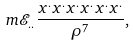Convert formula to latex. <formula><loc_0><loc_0><loc_500><loc_500>m \mathcal { E } _ { . . } \frac { x ^ { . } x ^ { . } x ^ { . } x ^ { . } x ^ { . } x ^ { . } } { \rho ^ { 7 } } ,</formula> 